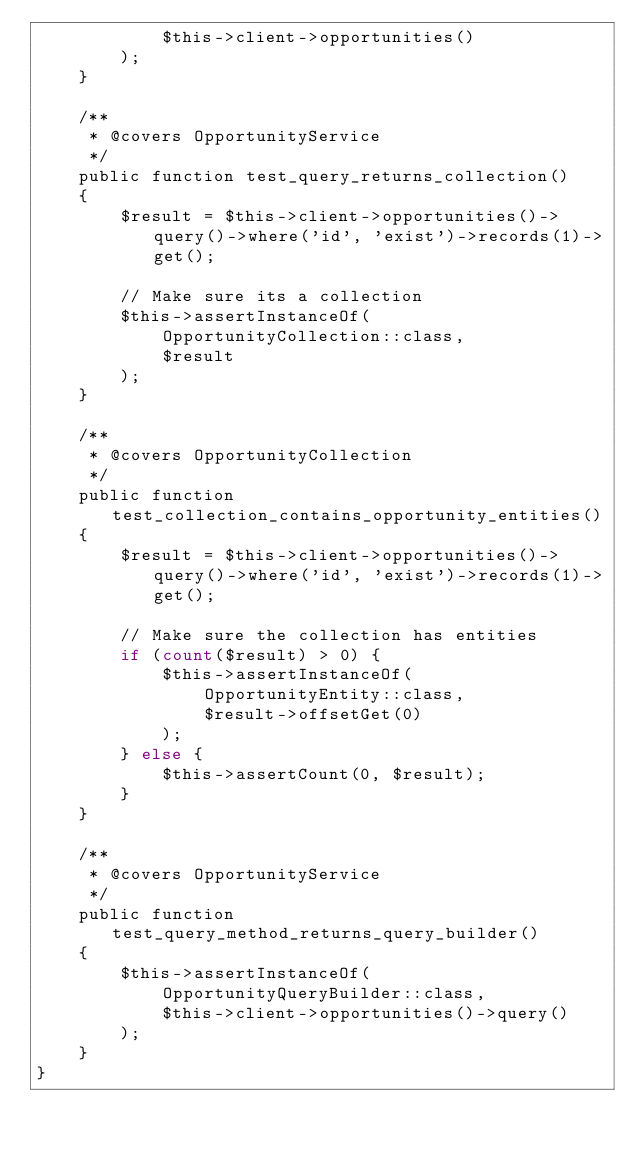Convert code to text. <code><loc_0><loc_0><loc_500><loc_500><_PHP_>            $this->client->opportunities()
        );
    }

    /**
     * @covers OpportunityService
     */
    public function test_query_returns_collection()
    {
        $result = $this->client->opportunities()->query()->where('id', 'exist')->records(1)->get();

        // Make sure its a collection
        $this->assertInstanceOf(
            OpportunityCollection::class,
            $result
        );
    }

    /**
     * @covers OpportunityCollection
     */
    public function test_collection_contains_opportunity_entities()
    {
        $result = $this->client->opportunities()->query()->where('id', 'exist')->records(1)->get();

        // Make sure the collection has entities
        if (count($result) > 0) {
            $this->assertInstanceOf(
                OpportunityEntity::class,
                $result->offsetGet(0)
            );
        } else {
            $this->assertCount(0, $result);
        }
    }

    /**
     * @covers OpportunityService
     */
    public function test_query_method_returns_query_builder()
    {
        $this->assertInstanceOf(
            OpportunityQueryBuilder::class,
            $this->client->opportunities()->query()
        );
    }
}
</code> 